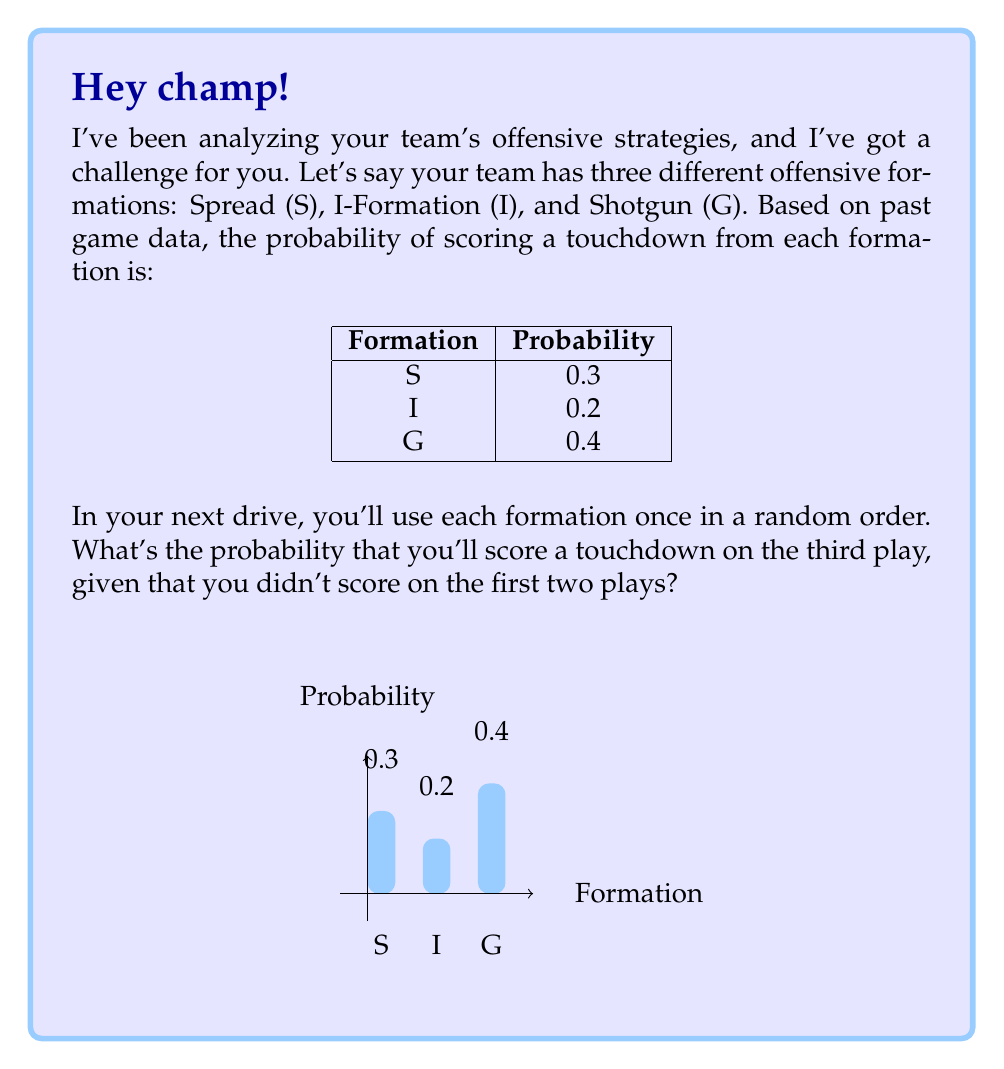Give your solution to this math problem. Let's approach this step-by-step:

1) First, we need to calculate the probability of not scoring a touchdown for each formation:
   S: $1 - 0.3 = 0.7$
   I: $1 - 0.2 = 0.8$
   G: $1 - 0.4 = 0.6$

2) The probability of not scoring in the first two plays is the product of the probabilities of not scoring in each of those plays. There are 6 possible orders for the three formations:

   SIG, SGI, ISG, IGS, GSI, GIS

3) For each order, we calculate the probability of not scoring in the first two plays and scoring in the third:

   SIG: $0.7 \times 0.8 \times 0.4 = 0.224$
   SGI: $0.7 \times 0.6 \times 0.2 = 0.084$
   ISG: $0.8 \times 0.7 \times 0.4 = 0.224$
   IGS: $0.8 \times 0.6 \times 0.3 = 0.144$
   GSI: $0.6 \times 0.7 \times 0.2 = 0.084$
   GIS: $0.6 \times 0.8 \times 0.3 = 0.144$

4) The total probability is the sum of these probabilities:

   $0.224 + 0.084 + 0.224 + 0.144 + 0.084 + 0.144 = 0.904$

5) However, this sum represents the probability of these specific sequences out of all possible sequences. We need to divide by the probability of not scoring in the first two plays to get our conditional probability.

6) The probability of not scoring in the first two plays is:

   $(0.7 + 0.8 + 0.6) \times (0.7 + 0.8 + 0.6) / 3 = 2.1 \times 2.1 / 3 = 1.47$

7) Therefore, our final probability is:

   $0.904 / 1.47 \approx 0.6150$
Answer: $\frac{226}{367} \approx 0.6150$ 